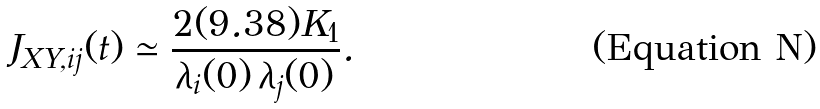<formula> <loc_0><loc_0><loc_500><loc_500>J _ { X Y , i j } ( t ) \simeq \frac { 2 ( 9 . 3 8 ) K _ { 1 } } { \lambda _ { i } ( 0 ) \, \lambda _ { j } ( 0 ) } .</formula> 